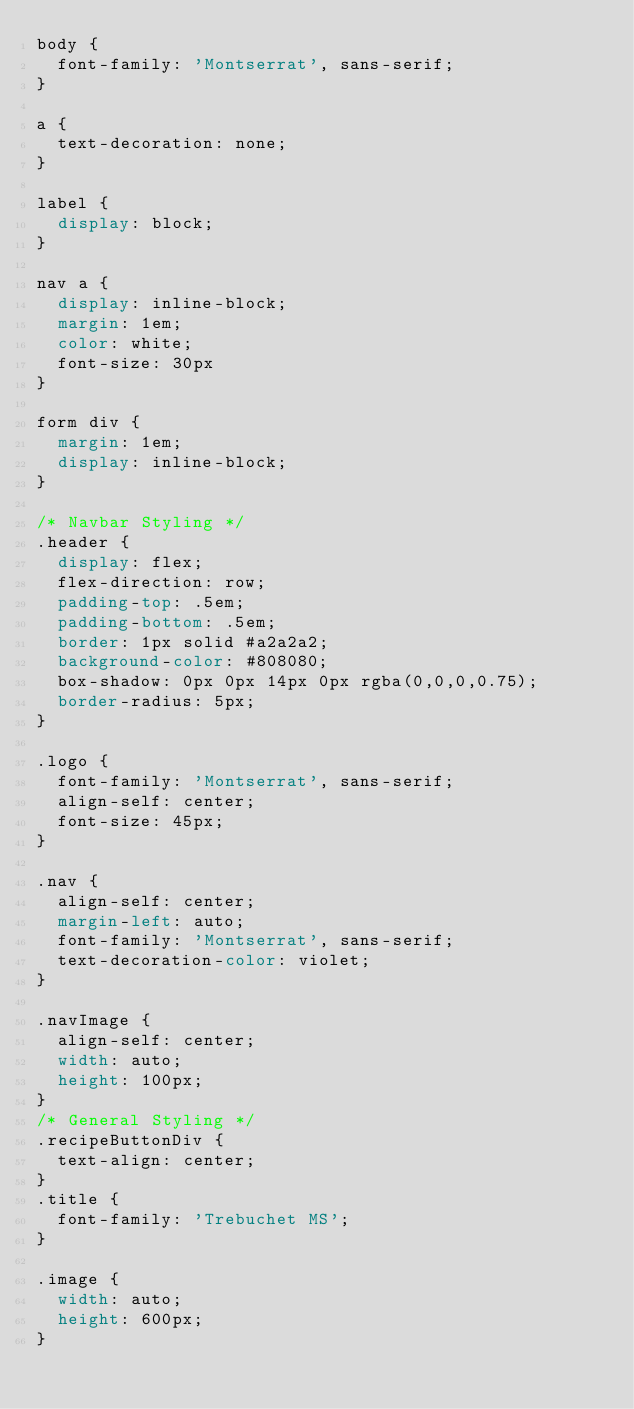Convert code to text. <code><loc_0><loc_0><loc_500><loc_500><_CSS_>body {
  font-family: 'Montserrat', sans-serif;
}

a {
  text-decoration: none;
}

label {
  display: block;
}

nav a {
  display: inline-block;
  margin: 1em;
  color: white;
  font-size: 30px
}

form div {
  margin: 1em;
  display: inline-block;
}

/* Navbar Styling */
.header {
  display: flex;
  flex-direction: row;
	padding-top: .5em;
	padding-bottom: .5em;
	border: 1px solid #a2a2a2;
	background-color: #808080;
	box-shadow: 0px 0px 14px 0px rgba(0,0,0,0.75);
	border-radius: 5px;
}

.logo {
	font-family: 'Montserrat', sans-serif;
  align-self: center;
  font-size: 45px;
}

.nav {
  align-self: center;
  margin-left: auto;
  font-family: 'Montserrat', sans-serif;
  text-decoration-color: violet;
}

.navImage {
  align-self: center;
  width: auto;
  height: 100px;
}
/* General Styling */
.recipeButtonDiv {
  text-align: center;
}
.title {
  font-family: 'Trebuchet MS';
}

.image {
  width: auto;
  height: 600px;
}

</code> 